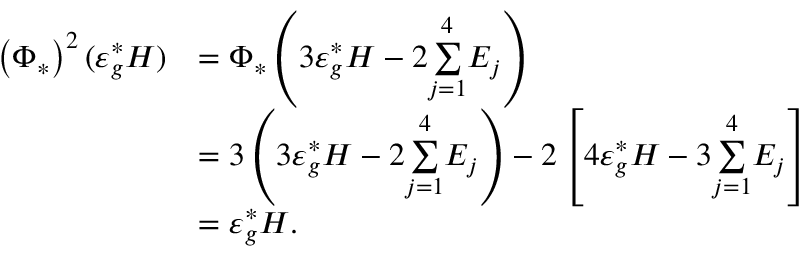<formula> <loc_0><loc_0><loc_500><loc_500>\begin{array} { r l } { \left ( \Phi _ { * } \right ) ^ { 2 } ( \varepsilon _ { g } ^ { * } H ) } & { = \Phi _ { * } \left ( 3 \varepsilon _ { g } ^ { * } H - 2 \underset { j = 1 } { \overset { 4 } { \sum } } E _ { j } \right ) } \\ & { = 3 \left ( 3 \varepsilon _ { g } ^ { * } H - 2 \underset { j = 1 } { \overset { 4 } { \sum } } E _ { j } \right ) - 2 \left [ 4 \varepsilon _ { g } ^ { * } H - 3 \underset { j = 1 } { \overset { 4 } { \sum } } E _ { j } \right ] } \\ & { = \varepsilon _ { g } ^ { * } H . } \end{array}</formula> 